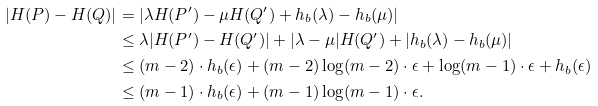Convert formula to latex. <formula><loc_0><loc_0><loc_500><loc_500>| H ( P ) - H ( Q ) | & = | \lambda H ( P ^ { \prime } ) - \mu H ( Q ^ { \prime } ) + h _ { b } ( \lambda ) - h _ { b } ( \mu ) | \\ & \leq \lambda | H ( P ^ { \prime } ) - H ( Q ^ { \prime } ) | + | \lambda - \mu | H ( Q ^ { \prime } ) + | h _ { b } ( \lambda ) - h _ { b } ( \mu ) | \\ & \leq ( m - 2 ) \cdot h _ { b } ( \epsilon ) + ( m - 2 ) \log ( m - 2 ) \cdot \epsilon + \log ( m - 1 ) \cdot \epsilon + h _ { b } ( \epsilon ) \\ & \leq ( m - 1 ) \cdot h _ { b } ( \epsilon ) + ( m - 1 ) \log ( m - 1 ) \cdot \epsilon .</formula> 